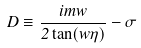<formula> <loc_0><loc_0><loc_500><loc_500>D \equiv \frac { i m w } { 2 \tan ( w \eta ) } - \sigma</formula> 